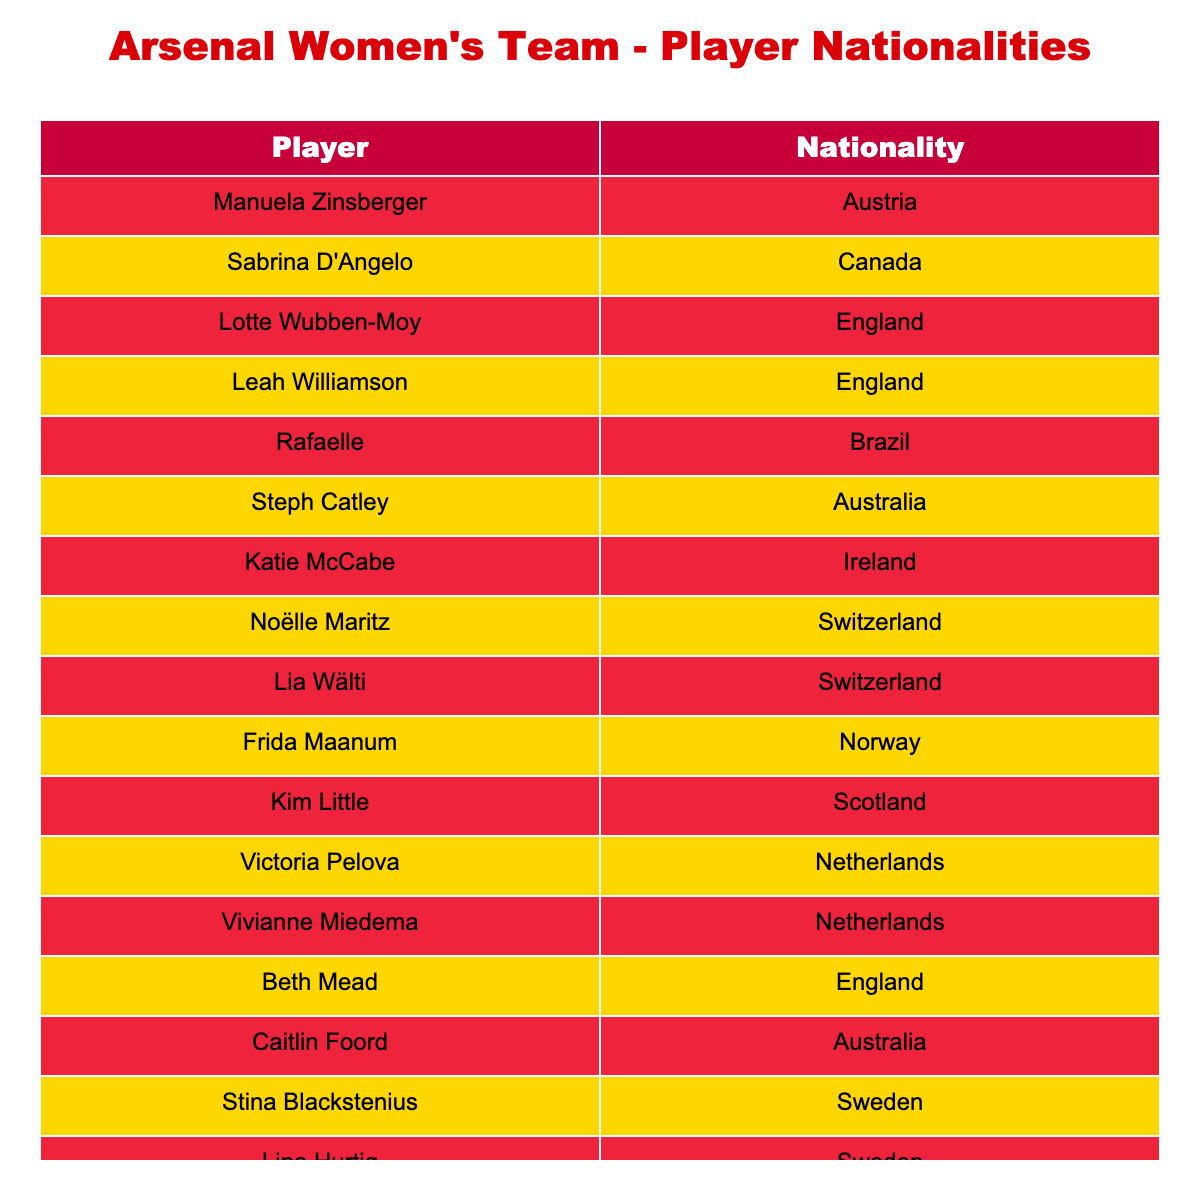What is the nationality of Vivianne Miedema? The table lists the nationality for each player. By locating Vivianne Miedema in the Player column, I can see that her nationality is Netherlands.
Answer: Netherlands How many players in the squad are from England? The table lists multiple players from the England nationality. I count Leah Williamson, Lotte Wubben-Moy, Beth Mead, making a total of 3 players from England.
Answer: 3 Are there more players from Australia or Sweden in the squad? From the table, I find 2 players from Australia (Steph Catley, Caitlin Foord) and 2 players from Sweden (Stina Blackstenius, Lina Hurtig). Since both totals are equal, there are not more players from either nationality.
Answer: No Which nationality has players other than England? Analyzing the table, I check all nationalities. Apart from England, I find Austria, Canada, Brazil, Australia, Ireland, Switzerland, Norway, Scotland, Netherlands, and Sweden listed. Thus, many nationalities have players apart from England.
Answer: Yes What is the total number of different nationalities represented in the squad? I first identify each unique nationality from the Nationality column in the table. The distinct nationalities I find are Austria, Canada, England, Brazil, Australia, Ireland, Switzerland, Norway, Scotland, Netherlands, and Sweden. Counting these gives a total of 11 different nationalities.
Answer: 11 How many players are from Brazil and Canada combined? From the table, I find 1 player from Brazil (Rafaelle) and 1 player from Canada (Sabrina D'Angelo). Combining these numbers, I find that there are 1 + 1 = 2 players from Brazil and Canada combined.
Answer: 2 Is Kim Little the only player from Scotland? I look at the Nationality column to check for players from Scotland. Kim Little is the only player listed whose nationality is Scotland. Therefore, the statement is true.
Answer: Yes Which country has the highest representation in the team? Looking through the table, I count the number of players per nationality. The results are: England (3), Australia (2), Sweden (2), and several countries with fewer players. Since England has the highest count of 3, this is the country with the highest representation.
Answer: England 